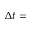<formula> <loc_0><loc_0><loc_500><loc_500>\Delta t =</formula> 